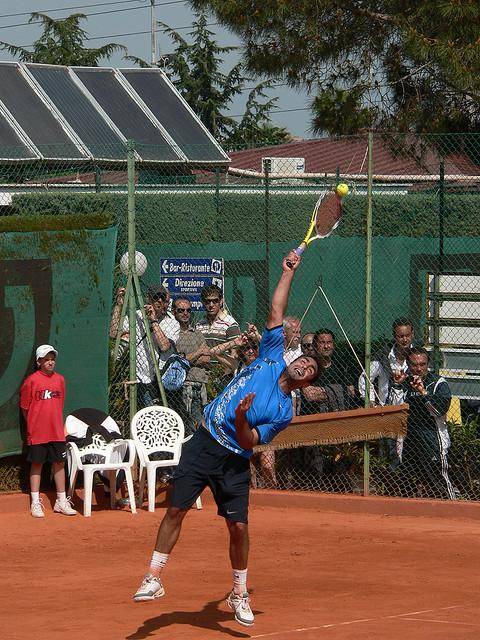Why is his arm so high in the air? hit ball 